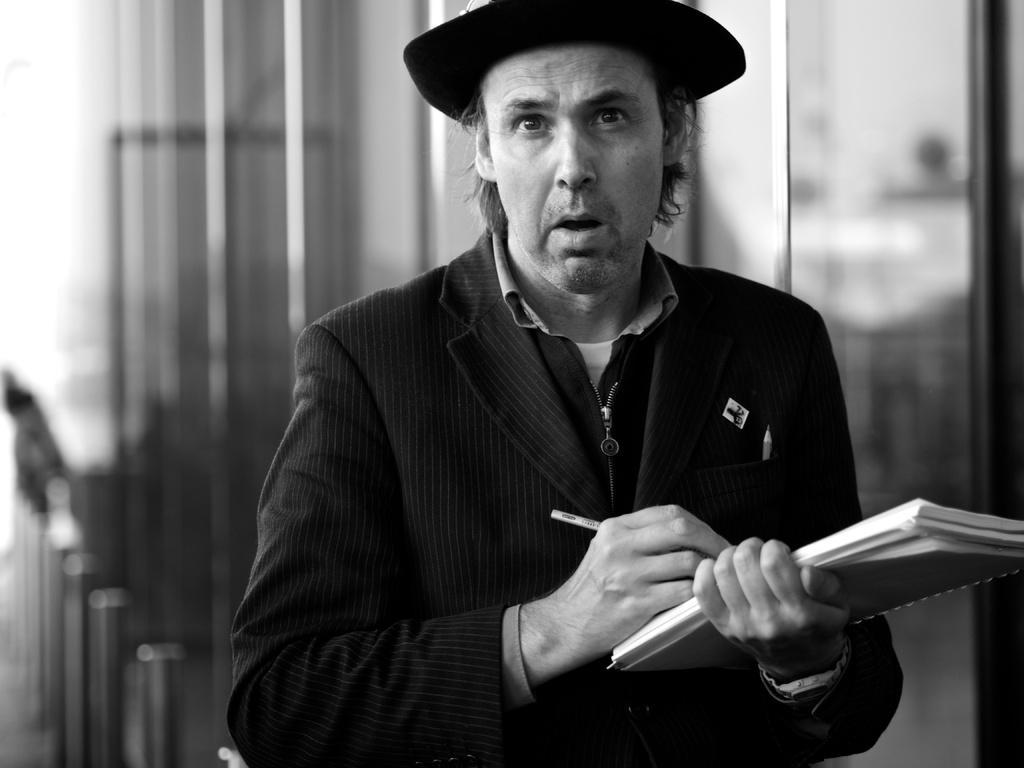What is the color scheme of the image? The image is black and white. Can you describe the person in the image? The person in the image is wearing a hat and holding a book and a pen. What is the person doing with the book and pen? The person is likely reading or writing, as they are holding a book and a pen. Are there any accessories visible on the person? Yes, there are glasses visible on the backside of the person. What type of pot is being used to bake the loaf of bread in the image? There is no pot or loaf of bread present in the image; it features a person wearing a hat, holding a book and a pen, and wearing glasses. 